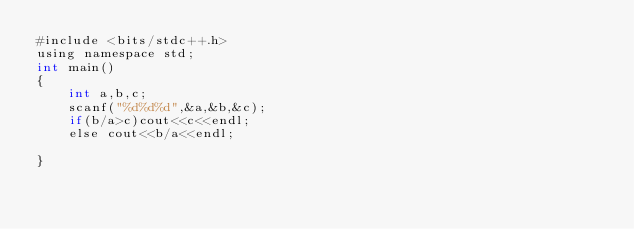<code> <loc_0><loc_0><loc_500><loc_500><_Awk_>#include <bits/stdc++.h>
using namespace std;
int main()
{
    int a,b,c;
    scanf("%d%d%d",&a,&b,&c);
    if(b/a>c)cout<<c<<endl;
    else cout<<b/a<<endl;
    
}</code> 